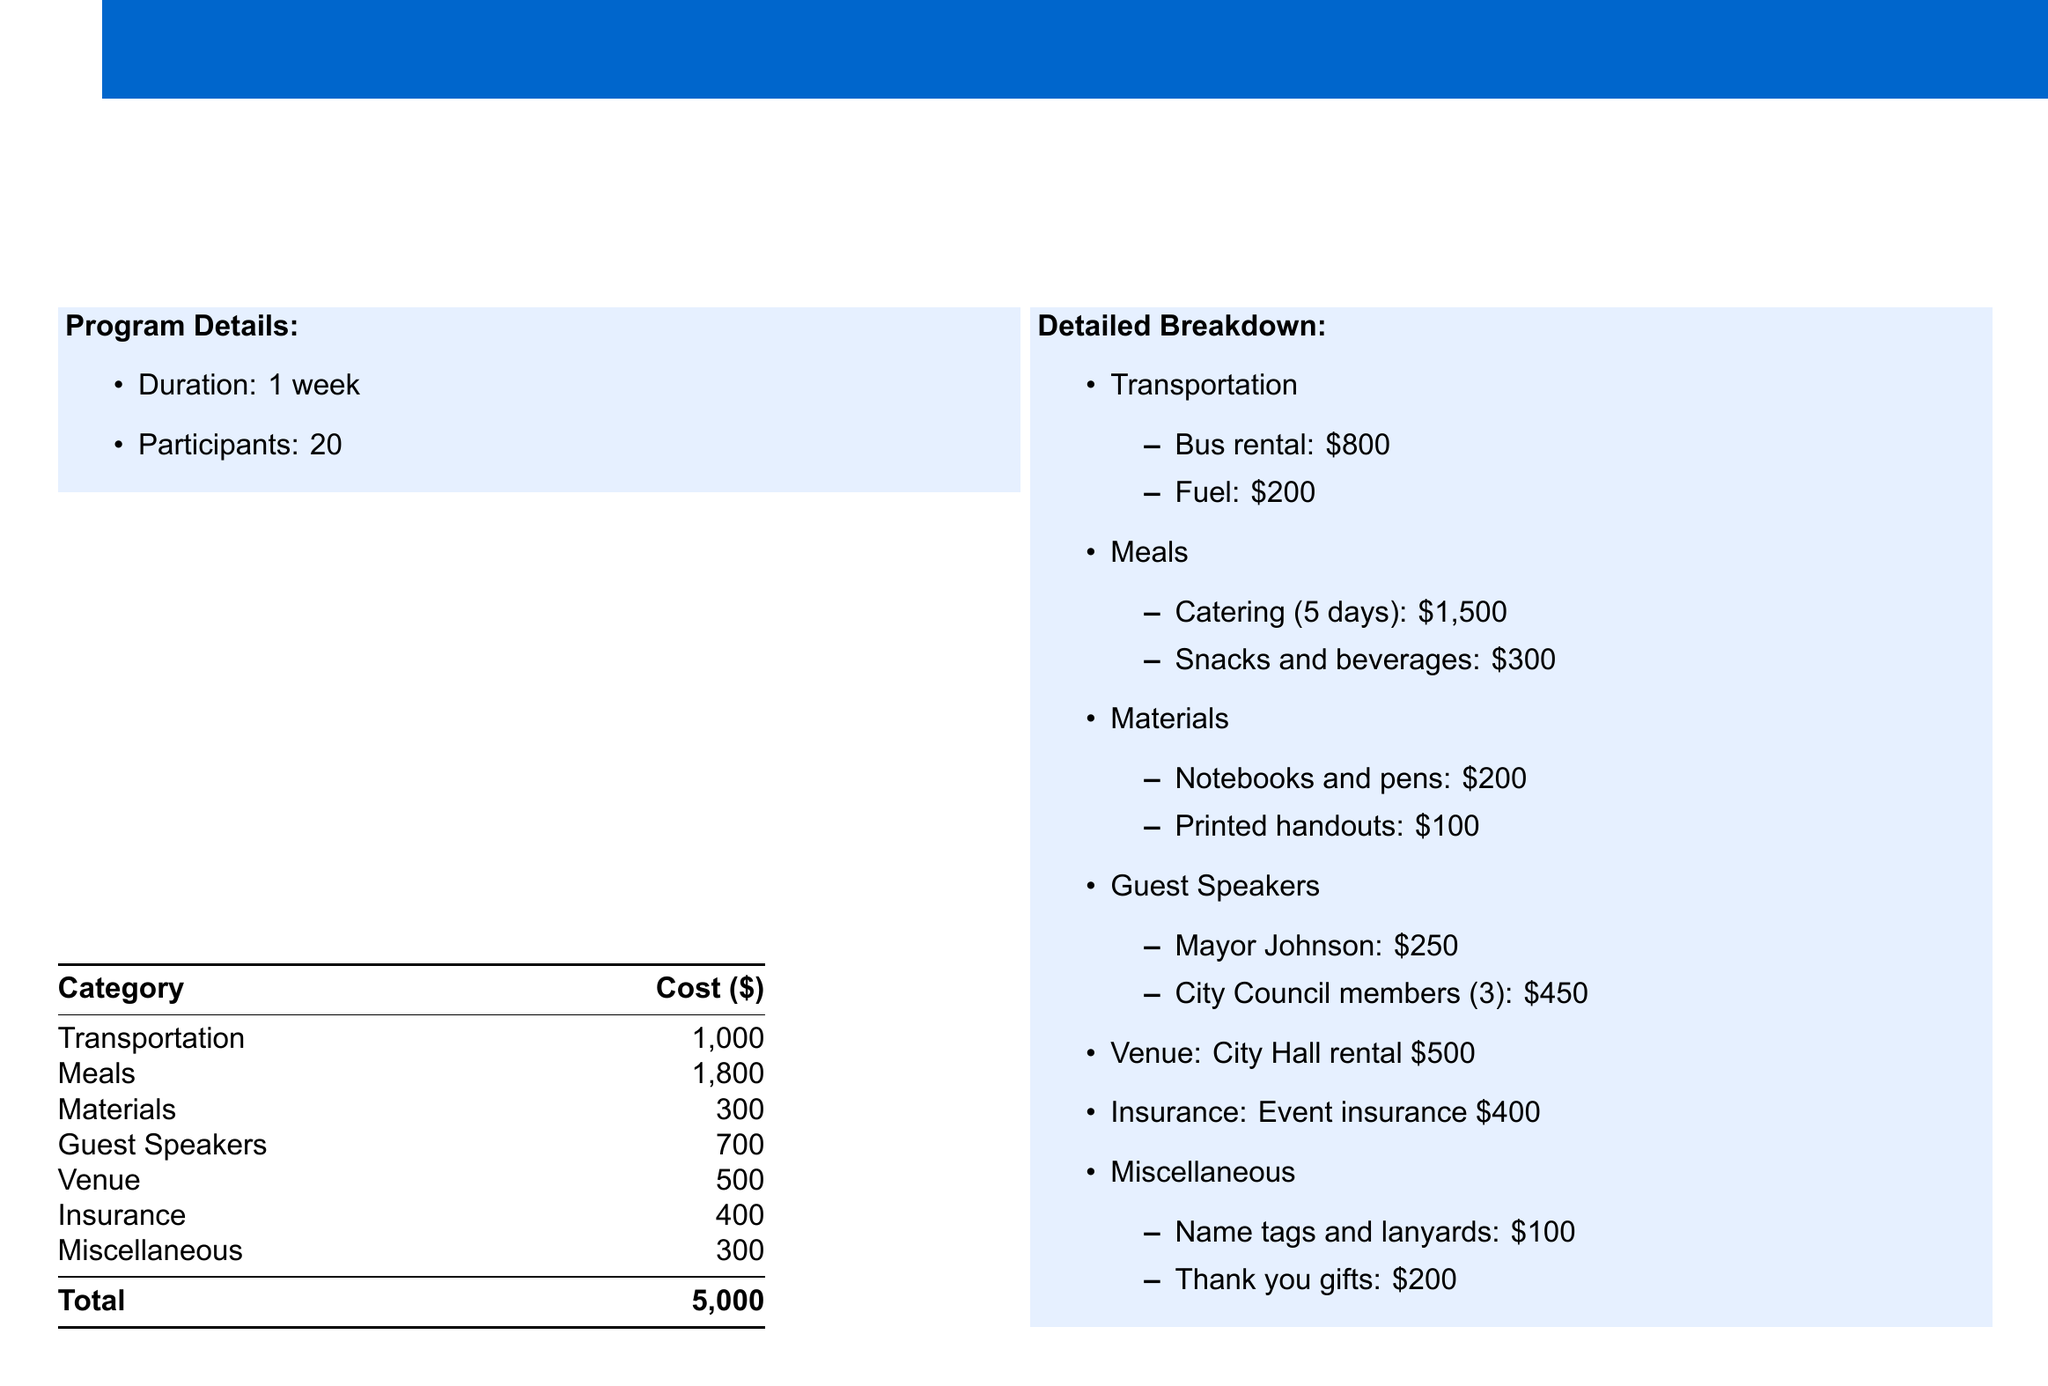What is the total cost of the program? The total cost is the final figure summarized at the bottom of the budget table.
Answer: 5,000 How many participants are there? The number of participants is specified in the program details section.
Answer: 20 What is the cost for guest speakers? The cost associated with guest speakers is detailed in the budget table.
Answer: 700 How much is allocated for meals? The amount allocated for meals is clearly stated in the cost breakdown.
Answer: 1,800 What are the costs for transportation? The transportation costs include bus rental and fuel, which are detailed in the breakdown section.
Answer: 1,000 What is the cost for insurance? The cost for insurance is indicated separately in the budget summary.
Answer: 400 Which item has the highest cost? By reviewing the detailed breakdown, the item with the highest cost can be identified.
Answer: Meals What is included in miscellaneous expenses? Miscellaneous expenses consist of name tags and thank you gifts, as outlined in the document.
Answer: Name tags and lanyards, thank you gifts How much is allocated for venue rental? The cost of venue rental is specified within the budget table.
Answer: 500 